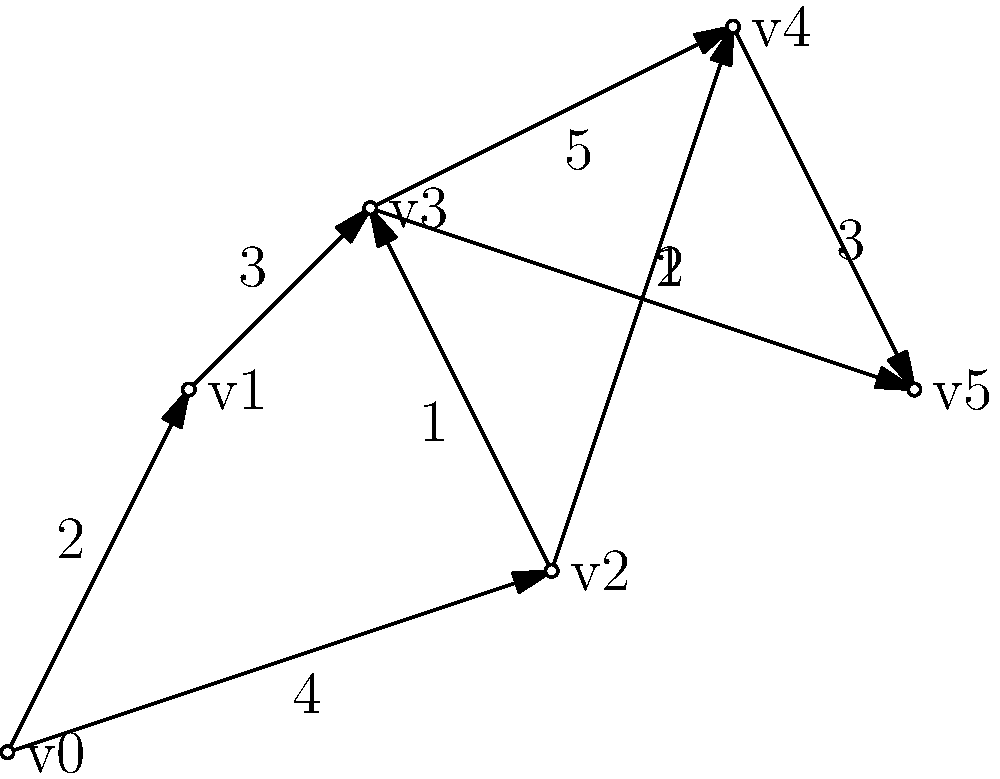In a digital painting application, brush strokes are represented as vertices in a graph, and the transitions between strokes are represented as weighted edges. The weights indicate the computational cost of transitioning between strokes. Given the graph above, what is the minimum cost path from vertex v0 to v5, and what is its total cost? Assume that the path must follow the direction of the arrows. To solve this problem, we can use Dijkstra's algorithm for finding the shortest path in a weighted directed graph. Let's go through the steps:

1. Initialize distances:
   v0: 0
   v1, v2, v3, v4, v5: infinity

2. Start from v0 and update its neighbors:
   v1: 2
   v2: 4

3. Choose the vertex with the smallest distance (v1) and update its neighbors:
   v3: 2 + 3 = 5

4. Choose the next smallest distance (v2) and update its neighbors:
   v3: min(5, 4 + 1) = 5
   v4: 4 + 2 = 6

5. Choose v3 and update its neighbors:
   v4: min(6, 5 + 5) = 6
   v5: 5 + 1 = 6

6. Choose v4 and update its neighbors:
   v5: min(6, 6 + 3) = 6

7. The algorithm terminates as we've reached v5.

The minimum cost path is v0 → v1 → v3 → v5, with a total cost of 2 + 3 + 1 = 6.
Answer: Path: v0 → v1 → v3 → v5; Cost: 6 